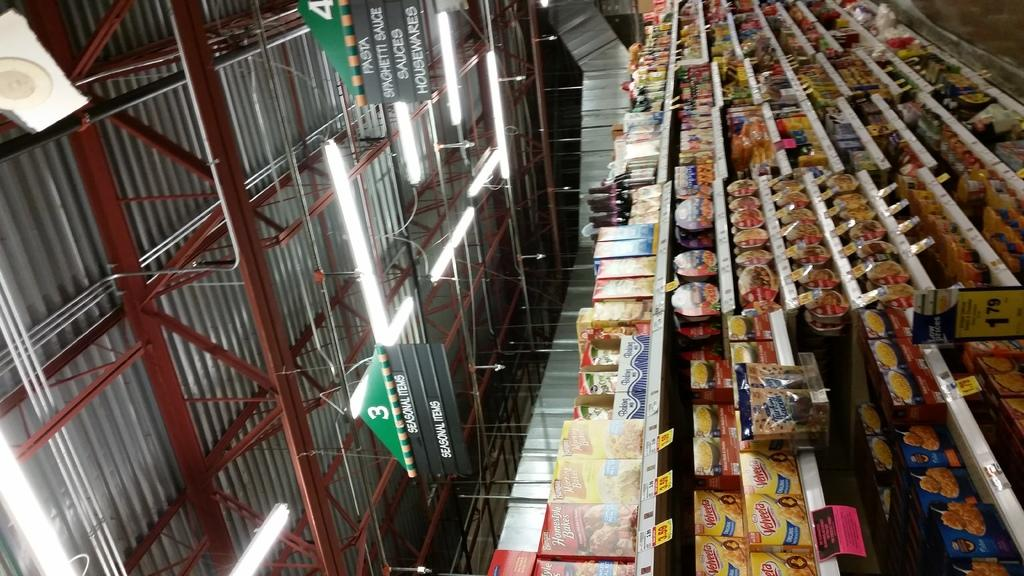Provide a one-sentence caption for the provided image. the inside of a store with a green sign on the top of it that says 3. 